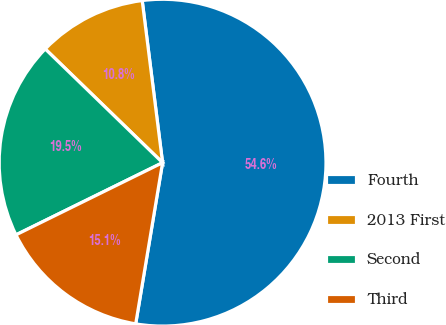<chart> <loc_0><loc_0><loc_500><loc_500><pie_chart><fcel>Fourth<fcel>2013 First<fcel>Second<fcel>Third<nl><fcel>54.62%<fcel>10.76%<fcel>19.53%<fcel>15.09%<nl></chart> 